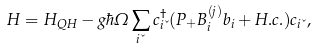Convert formula to latex. <formula><loc_0><loc_0><loc_500><loc_500>H = H _ { Q H } - g \hbar { \Omega } \sum _ { i \kappa } c _ { i \kappa } ^ { \dagger } ( P _ { + } B _ { i } ^ { ( j ) } b _ { i } + H . c . ) c _ { i \kappa } ,</formula> 